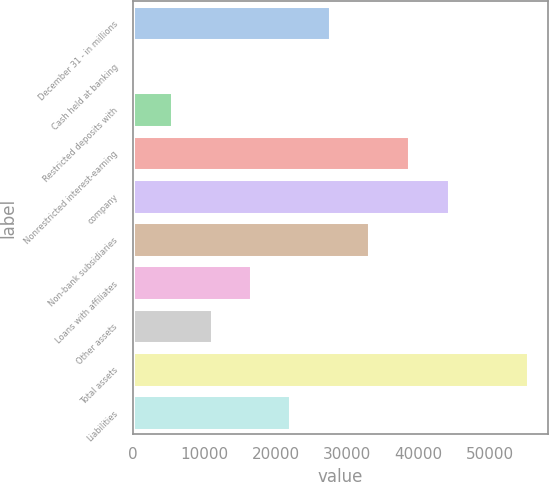Convert chart. <chart><loc_0><loc_0><loc_500><loc_500><bar_chart><fcel>December 31 - in millions<fcel>Cash held at banking<fcel>Restricted deposits with<fcel>Nonrestricted interest-earning<fcel>company<fcel>Non-bank subsidiaries<fcel>Loans with affiliates<fcel>Other assets<fcel>Total assets<fcel>Liabilities<nl><fcel>27611<fcel>1<fcel>5523<fcel>38655<fcel>44360<fcel>33133<fcel>16567<fcel>11045<fcel>55404<fcel>22089<nl></chart> 